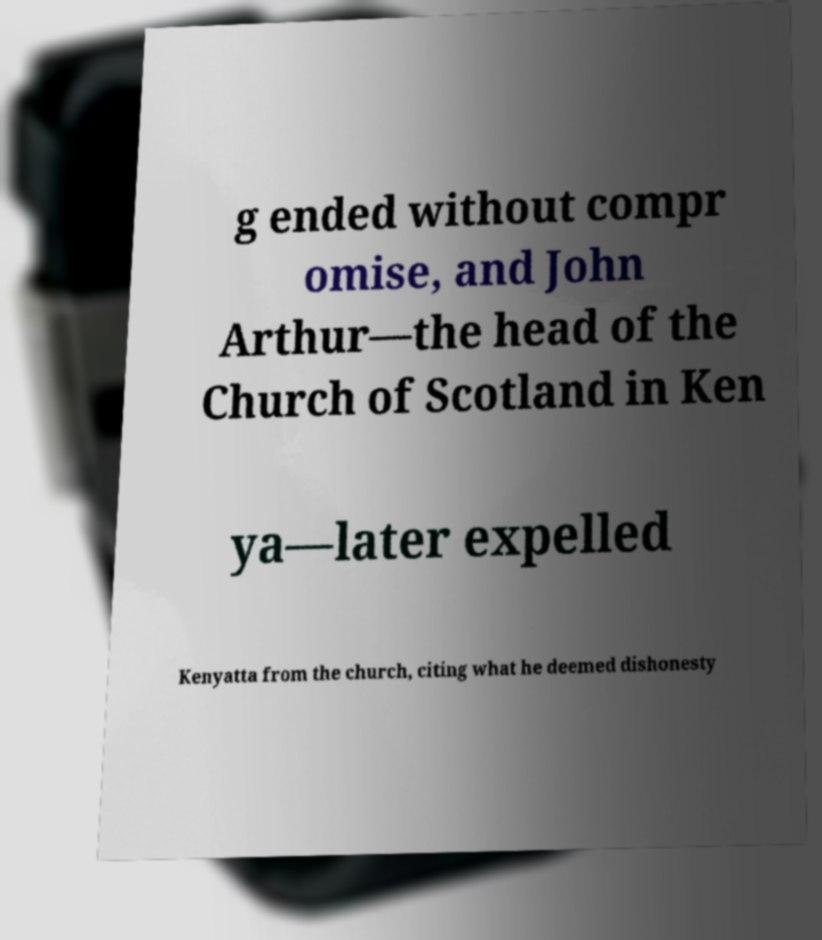I need the written content from this picture converted into text. Can you do that? g ended without compr omise, and John Arthur—the head of the Church of Scotland in Ken ya—later expelled Kenyatta from the church, citing what he deemed dishonesty 